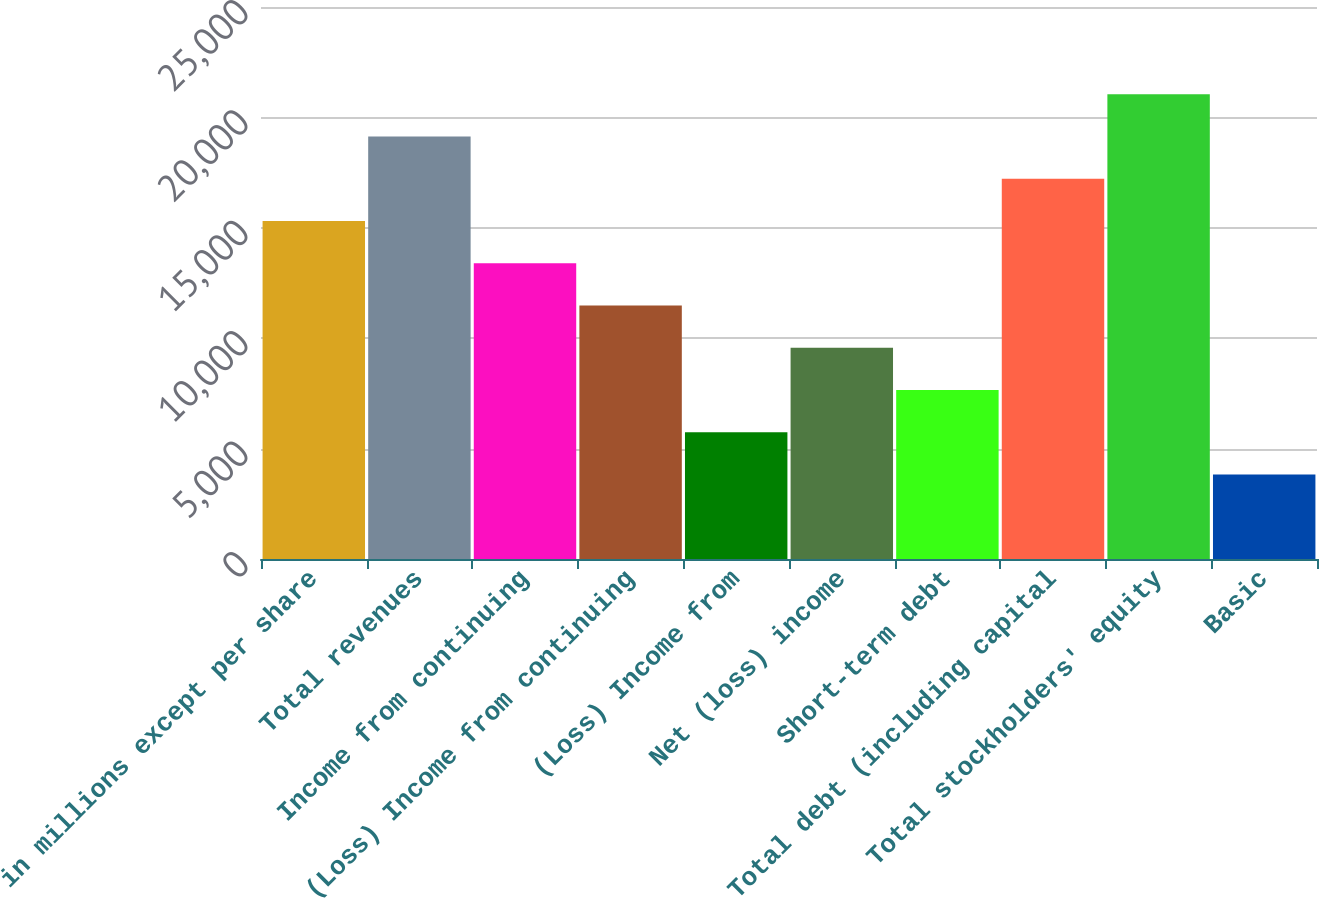<chart> <loc_0><loc_0><loc_500><loc_500><bar_chart><fcel>in millions except per share<fcel>Total revenues<fcel>Income from continuing<fcel>(Loss) Income from continuing<fcel>(Loss) Income from<fcel>Net (loss) income<fcel>Short-term debt<fcel>Total debt (including capital<fcel>Total stockholders' equity<fcel>Basic<nl><fcel>15304.1<fcel>19130<fcel>13391.2<fcel>11478.2<fcel>5739.45<fcel>9565.31<fcel>7652.38<fcel>17217<fcel>21042.9<fcel>3826.52<nl></chart> 